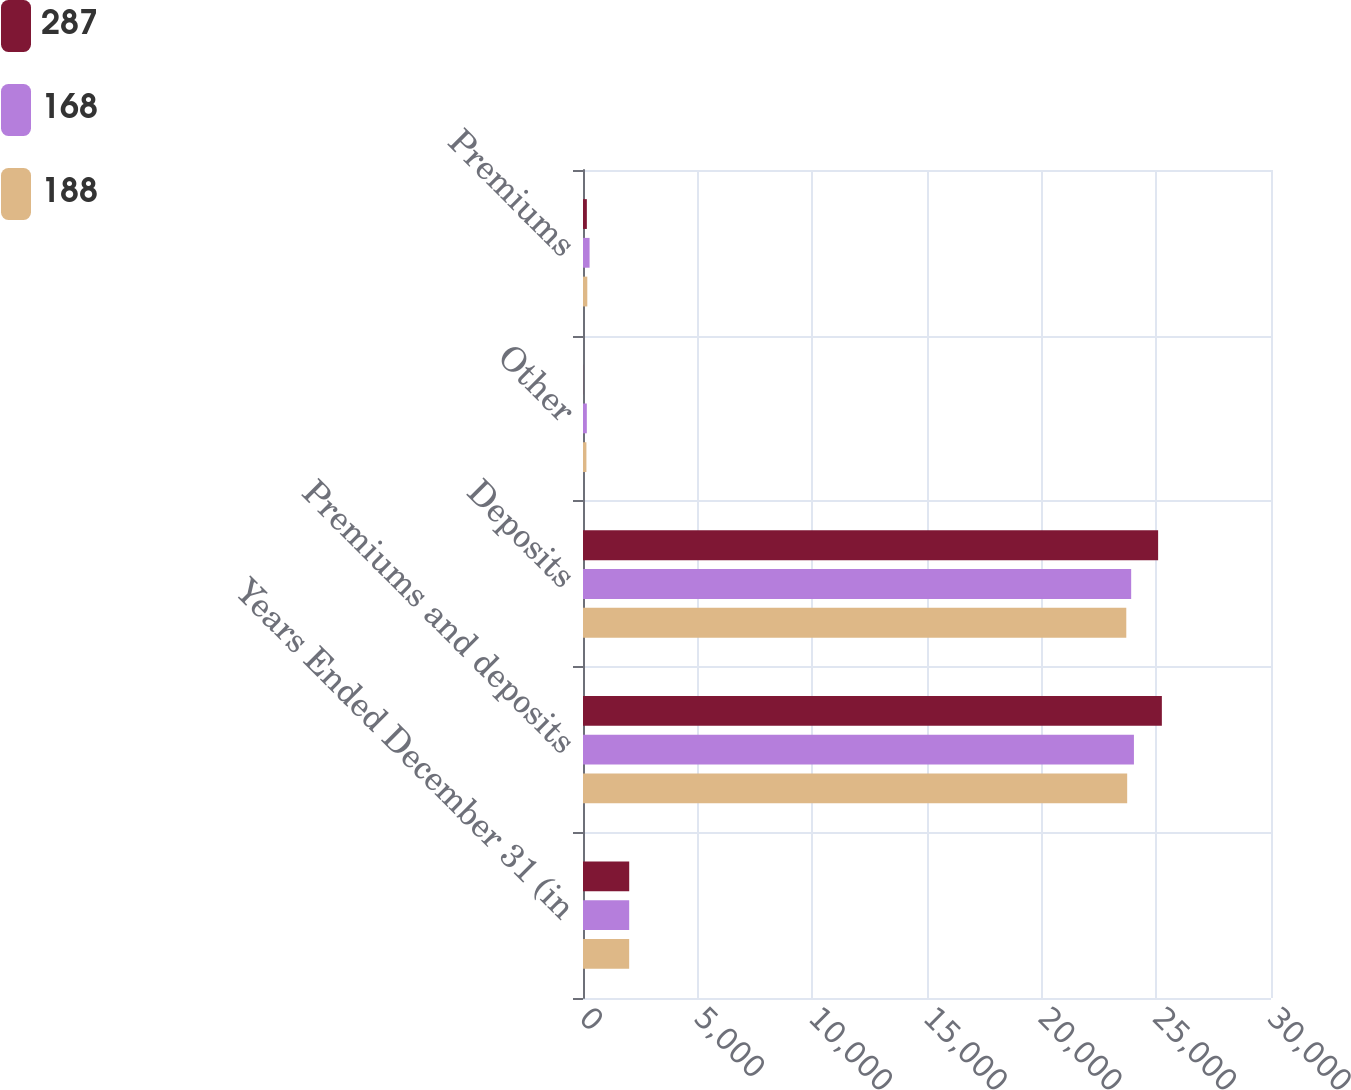Convert chart. <chart><loc_0><loc_0><loc_500><loc_500><stacked_bar_chart><ecel><fcel>Years Ended December 31 (in<fcel>Premiums and deposits<fcel>Deposits<fcel>Other<fcel>Premiums<nl><fcel>287<fcel>2015<fcel>25241<fcel>25078<fcel>5<fcel>168<nl><fcel>168<fcel>2014<fcel>24023<fcel>23903<fcel>167<fcel>287<nl><fcel>188<fcel>2013<fcel>23729<fcel>23690<fcel>149<fcel>188<nl></chart> 